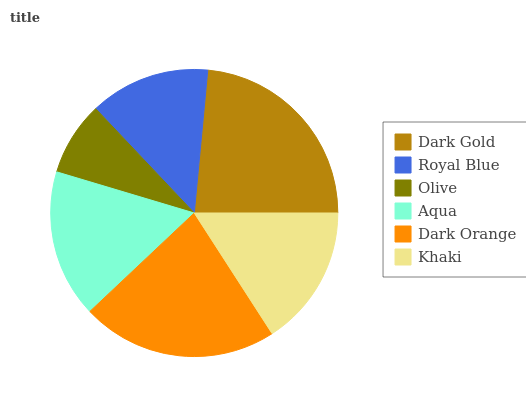Is Olive the minimum?
Answer yes or no. Yes. Is Dark Gold the maximum?
Answer yes or no. Yes. Is Royal Blue the minimum?
Answer yes or no. No. Is Royal Blue the maximum?
Answer yes or no. No. Is Dark Gold greater than Royal Blue?
Answer yes or no. Yes. Is Royal Blue less than Dark Gold?
Answer yes or no. Yes. Is Royal Blue greater than Dark Gold?
Answer yes or no. No. Is Dark Gold less than Royal Blue?
Answer yes or no. No. Is Aqua the high median?
Answer yes or no. Yes. Is Khaki the low median?
Answer yes or no. Yes. Is Dark Orange the high median?
Answer yes or no. No. Is Royal Blue the low median?
Answer yes or no. No. 